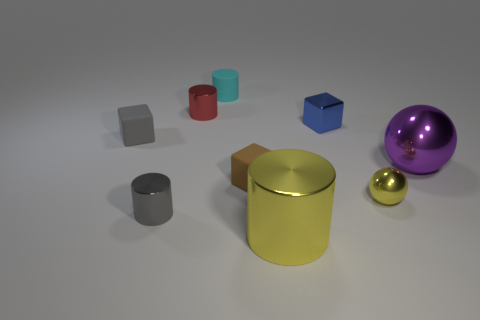How many other objects are there of the same color as the small ball?
Offer a terse response. 1. Are there the same number of purple metal balls left of the blue thing and small red cylinders behind the cyan rubber cylinder?
Your answer should be very brief. Yes. There is a cylinder right of the small cyan rubber cylinder; what is it made of?
Provide a succinct answer. Metal. Are there any other things that have the same size as the gray matte thing?
Make the answer very short. Yes. Are there fewer brown cubes than yellow metal objects?
Offer a terse response. Yes. The shiny thing that is both in front of the small yellow metal object and on the left side of the tiny cyan matte cylinder has what shape?
Your answer should be very brief. Cylinder. How many rubber blocks are there?
Ensure brevity in your answer.  2. There is a yellow object behind the tiny shiny cylinder that is in front of the gray object that is behind the brown matte thing; what is it made of?
Offer a terse response. Metal. There is a yellow metal thing in front of the gray cylinder; what number of red cylinders are on the right side of it?
Offer a terse response. 0. What color is the other shiny object that is the same shape as the big purple object?
Offer a very short reply. Yellow. 